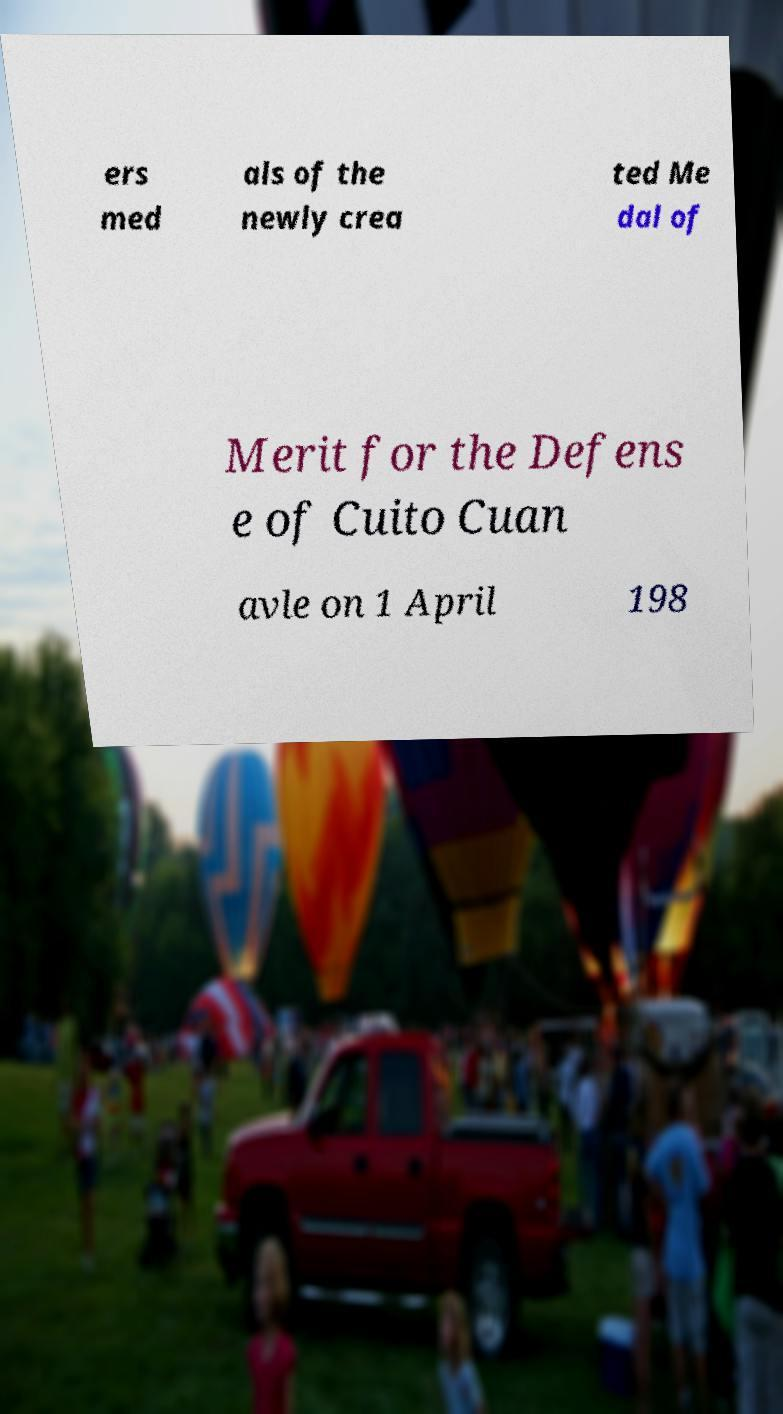Please identify and transcribe the text found in this image. ers med als of the newly crea ted Me dal of Merit for the Defens e of Cuito Cuan avle on 1 April 198 